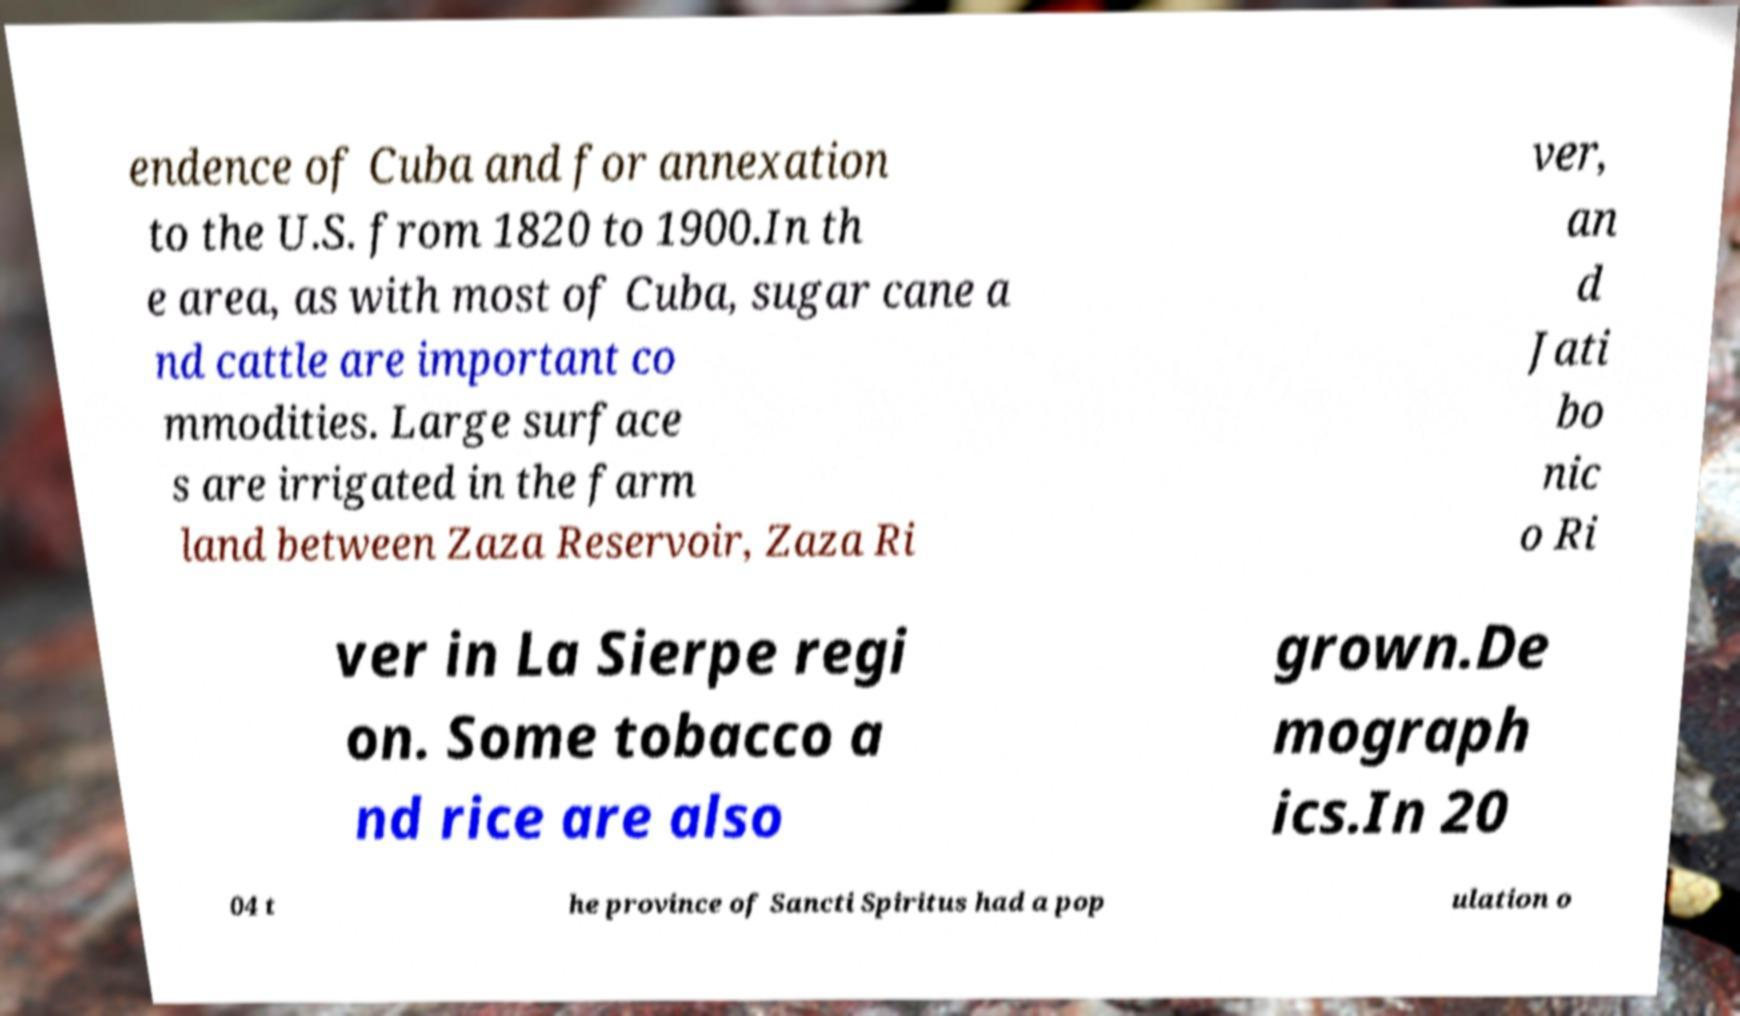For documentation purposes, I need the text within this image transcribed. Could you provide that? endence of Cuba and for annexation to the U.S. from 1820 to 1900.In th e area, as with most of Cuba, sugar cane a nd cattle are important co mmodities. Large surface s are irrigated in the farm land between Zaza Reservoir, Zaza Ri ver, an d Jati bo nic o Ri ver in La Sierpe regi on. Some tobacco a nd rice are also grown.De mograph ics.In 20 04 t he province of Sancti Spiritus had a pop ulation o 